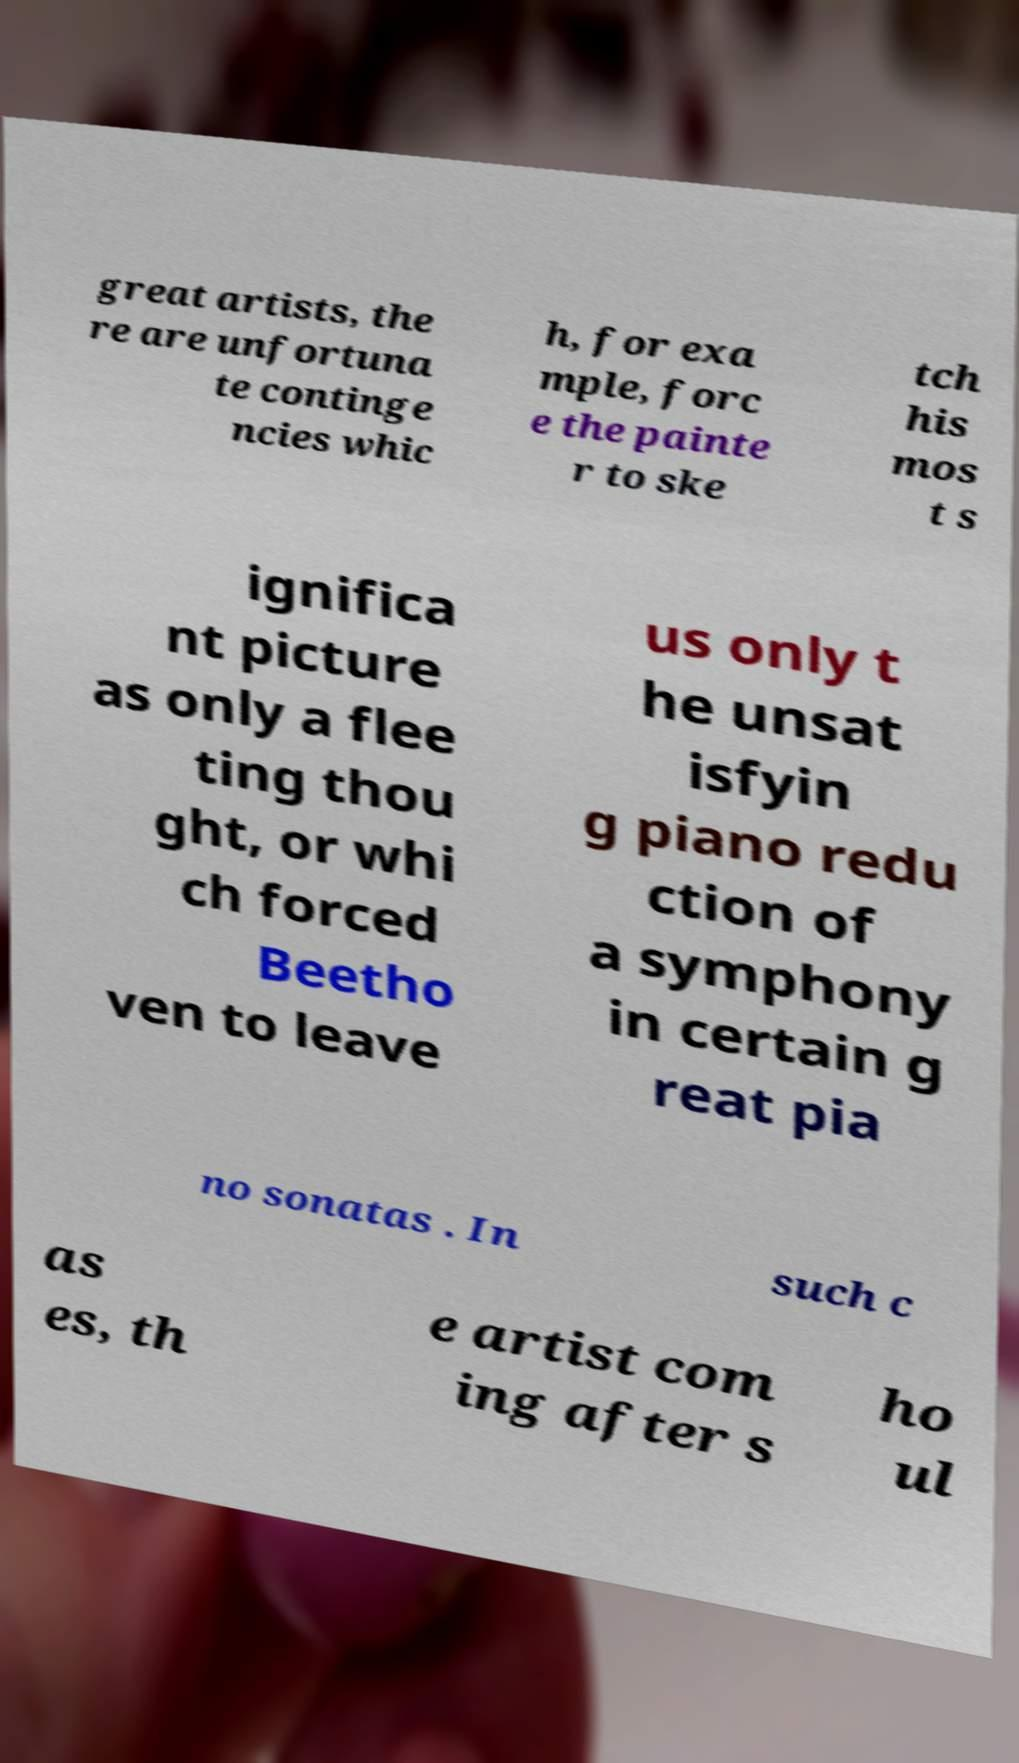Could you assist in decoding the text presented in this image and type it out clearly? great artists, the re are unfortuna te continge ncies whic h, for exa mple, forc e the painte r to ske tch his mos t s ignifica nt picture as only a flee ting thou ght, or whi ch forced Beetho ven to leave us only t he unsat isfyin g piano redu ction of a symphony in certain g reat pia no sonatas . In such c as es, th e artist com ing after s ho ul 